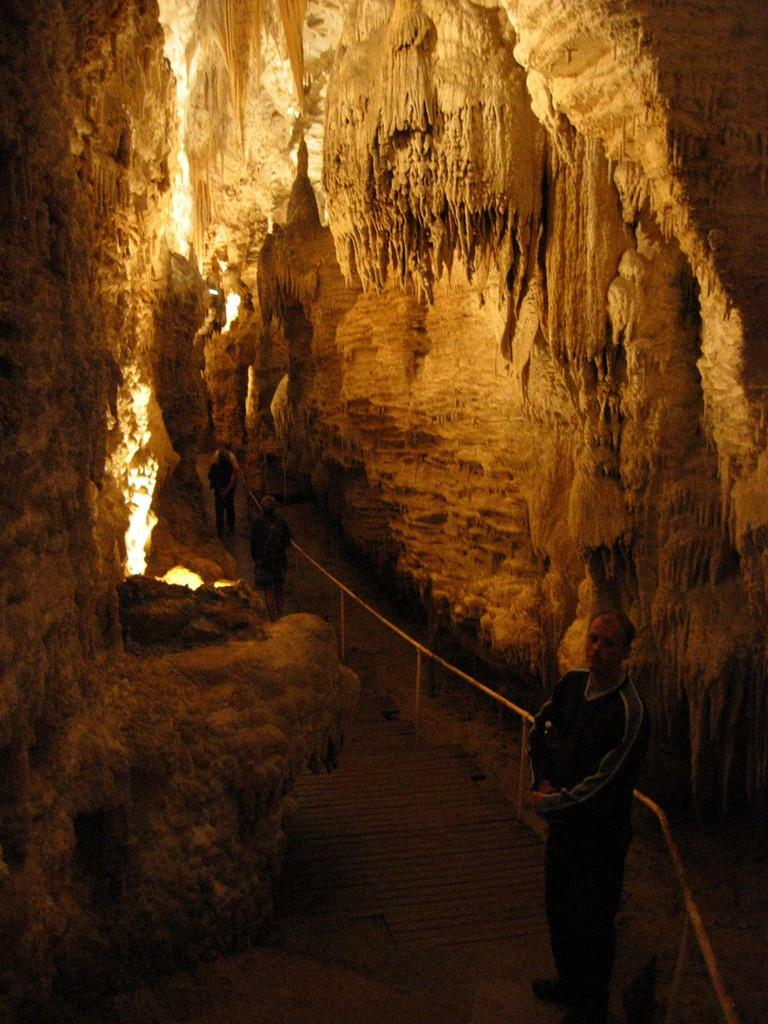What is the main feature of the image? There is a cave in the image. What can be seen inside the cave? There is a path inside the cave. What are the people in the image doing? People are walking on the path. What type of bean is being taught to the grass in the image? There is no bean or grass present in the image, and no teaching is taking place. 